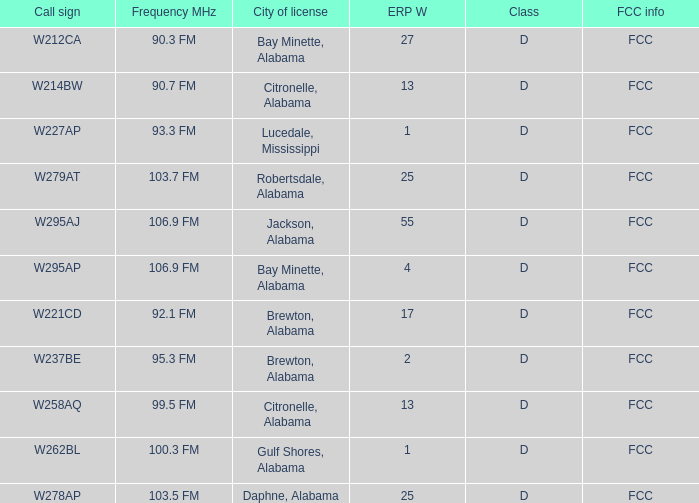Name the FCC info for call sign of w279at FCC. 